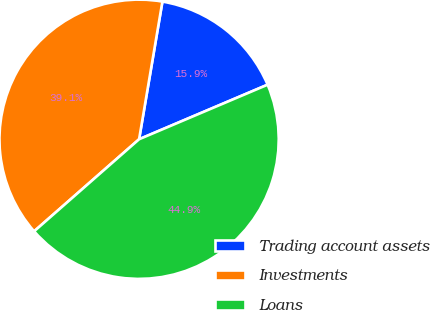Convert chart to OTSL. <chart><loc_0><loc_0><loc_500><loc_500><pie_chart><fcel>Trading account assets<fcel>Investments<fcel>Loans<nl><fcel>15.94%<fcel>39.13%<fcel>44.93%<nl></chart> 